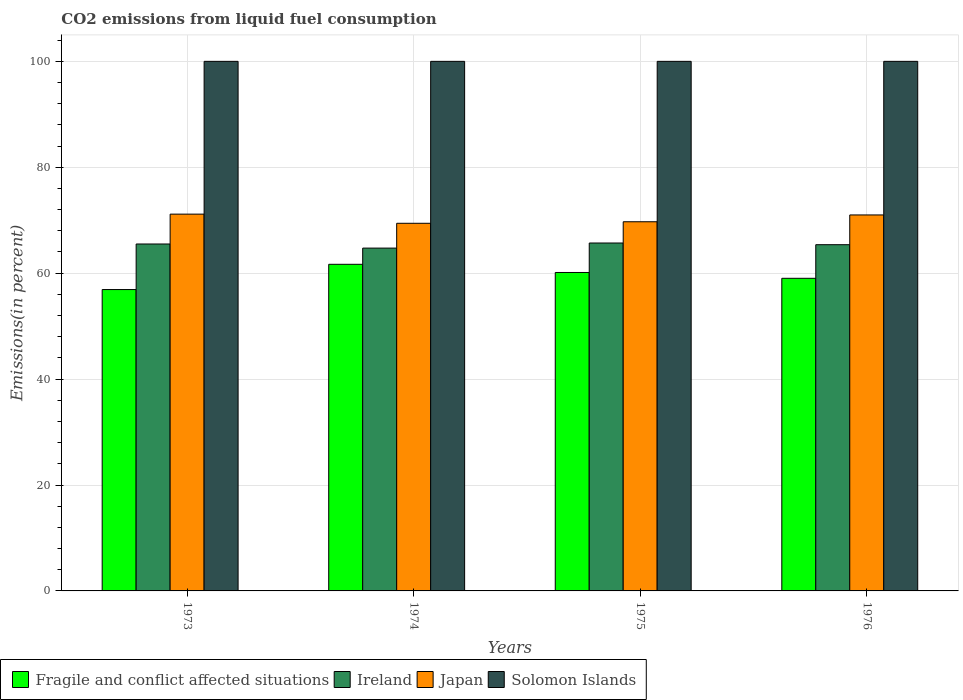How many groups of bars are there?
Your answer should be very brief. 4. Are the number of bars per tick equal to the number of legend labels?
Keep it short and to the point. Yes. Are the number of bars on each tick of the X-axis equal?
Give a very brief answer. Yes. What is the label of the 4th group of bars from the left?
Your response must be concise. 1976. In how many cases, is the number of bars for a given year not equal to the number of legend labels?
Make the answer very short. 0. What is the total CO2 emitted in Japan in 1974?
Your answer should be very brief. 69.42. Across all years, what is the maximum total CO2 emitted in Japan?
Provide a short and direct response. 71.15. Across all years, what is the minimum total CO2 emitted in Solomon Islands?
Give a very brief answer. 100. In which year was the total CO2 emitted in Japan maximum?
Provide a succinct answer. 1973. In which year was the total CO2 emitted in Ireland minimum?
Give a very brief answer. 1974. What is the total total CO2 emitted in Fragile and conflict affected situations in the graph?
Offer a very short reply. 237.75. What is the difference between the total CO2 emitted in Fragile and conflict affected situations in 1976 and the total CO2 emitted in Ireland in 1974?
Ensure brevity in your answer.  -5.7. What is the average total CO2 emitted in Ireland per year?
Offer a very short reply. 65.33. In the year 1973, what is the difference between the total CO2 emitted in Japan and total CO2 emitted in Ireland?
Give a very brief answer. 5.64. In how many years, is the total CO2 emitted in Ireland greater than 40 %?
Your response must be concise. 4. What is the ratio of the total CO2 emitted in Solomon Islands in 1975 to that in 1976?
Ensure brevity in your answer.  1. Is the total CO2 emitted in Fragile and conflict affected situations in 1973 less than that in 1975?
Keep it short and to the point. Yes. Is the difference between the total CO2 emitted in Japan in 1974 and 1975 greater than the difference between the total CO2 emitted in Ireland in 1974 and 1975?
Provide a succinct answer. Yes. What is the difference between the highest and the second highest total CO2 emitted in Fragile and conflict affected situations?
Provide a succinct answer. 1.54. What is the difference between the highest and the lowest total CO2 emitted in Solomon Islands?
Your answer should be very brief. 0. What does the 3rd bar from the right in 1974 represents?
Offer a very short reply. Ireland. Are all the bars in the graph horizontal?
Provide a short and direct response. No. How many years are there in the graph?
Your answer should be compact. 4. What is the difference between two consecutive major ticks on the Y-axis?
Provide a succinct answer. 20. Are the values on the major ticks of Y-axis written in scientific E-notation?
Provide a succinct answer. No. Does the graph contain grids?
Your response must be concise. Yes. How are the legend labels stacked?
Provide a short and direct response. Horizontal. What is the title of the graph?
Offer a very short reply. CO2 emissions from liquid fuel consumption. Does "New Caledonia" appear as one of the legend labels in the graph?
Provide a succinct answer. No. What is the label or title of the X-axis?
Give a very brief answer. Years. What is the label or title of the Y-axis?
Offer a very short reply. Emissions(in percent). What is the Emissions(in percent) of Fragile and conflict affected situations in 1973?
Your answer should be compact. 56.91. What is the Emissions(in percent) in Ireland in 1973?
Your response must be concise. 65.51. What is the Emissions(in percent) of Japan in 1973?
Make the answer very short. 71.15. What is the Emissions(in percent) in Solomon Islands in 1973?
Give a very brief answer. 100. What is the Emissions(in percent) in Fragile and conflict affected situations in 1974?
Your answer should be very brief. 61.68. What is the Emissions(in percent) of Ireland in 1974?
Keep it short and to the point. 64.74. What is the Emissions(in percent) of Japan in 1974?
Your response must be concise. 69.42. What is the Emissions(in percent) of Solomon Islands in 1974?
Make the answer very short. 100. What is the Emissions(in percent) of Fragile and conflict affected situations in 1975?
Provide a succinct answer. 60.13. What is the Emissions(in percent) in Ireland in 1975?
Give a very brief answer. 65.7. What is the Emissions(in percent) in Japan in 1975?
Your response must be concise. 69.71. What is the Emissions(in percent) in Fragile and conflict affected situations in 1976?
Provide a short and direct response. 59.03. What is the Emissions(in percent) of Ireland in 1976?
Offer a terse response. 65.38. What is the Emissions(in percent) in Japan in 1976?
Provide a short and direct response. 71. Across all years, what is the maximum Emissions(in percent) of Fragile and conflict affected situations?
Provide a short and direct response. 61.68. Across all years, what is the maximum Emissions(in percent) in Ireland?
Provide a short and direct response. 65.7. Across all years, what is the maximum Emissions(in percent) in Japan?
Offer a very short reply. 71.15. Across all years, what is the maximum Emissions(in percent) in Solomon Islands?
Offer a very short reply. 100. Across all years, what is the minimum Emissions(in percent) of Fragile and conflict affected situations?
Offer a terse response. 56.91. Across all years, what is the minimum Emissions(in percent) of Ireland?
Your response must be concise. 64.74. Across all years, what is the minimum Emissions(in percent) of Japan?
Ensure brevity in your answer.  69.42. Across all years, what is the minimum Emissions(in percent) in Solomon Islands?
Keep it short and to the point. 100. What is the total Emissions(in percent) of Fragile and conflict affected situations in the graph?
Keep it short and to the point. 237.75. What is the total Emissions(in percent) in Ireland in the graph?
Provide a succinct answer. 261.32. What is the total Emissions(in percent) in Japan in the graph?
Provide a short and direct response. 281.28. What is the difference between the Emissions(in percent) in Fragile and conflict affected situations in 1973 and that in 1974?
Provide a short and direct response. -4.77. What is the difference between the Emissions(in percent) of Ireland in 1973 and that in 1974?
Provide a short and direct response. 0.78. What is the difference between the Emissions(in percent) of Japan in 1973 and that in 1974?
Your answer should be very brief. 1.73. What is the difference between the Emissions(in percent) in Fragile and conflict affected situations in 1973 and that in 1975?
Provide a succinct answer. -3.23. What is the difference between the Emissions(in percent) of Ireland in 1973 and that in 1975?
Your answer should be compact. -0.18. What is the difference between the Emissions(in percent) of Japan in 1973 and that in 1975?
Your answer should be compact. 1.44. What is the difference between the Emissions(in percent) of Solomon Islands in 1973 and that in 1975?
Keep it short and to the point. 0. What is the difference between the Emissions(in percent) of Fragile and conflict affected situations in 1973 and that in 1976?
Offer a terse response. -2.12. What is the difference between the Emissions(in percent) in Ireland in 1973 and that in 1976?
Provide a short and direct response. 0.13. What is the difference between the Emissions(in percent) of Japan in 1973 and that in 1976?
Ensure brevity in your answer.  0.15. What is the difference between the Emissions(in percent) in Fragile and conflict affected situations in 1974 and that in 1975?
Give a very brief answer. 1.54. What is the difference between the Emissions(in percent) of Ireland in 1974 and that in 1975?
Provide a short and direct response. -0.96. What is the difference between the Emissions(in percent) in Japan in 1974 and that in 1975?
Give a very brief answer. -0.29. What is the difference between the Emissions(in percent) in Fragile and conflict affected situations in 1974 and that in 1976?
Give a very brief answer. 2.65. What is the difference between the Emissions(in percent) in Ireland in 1974 and that in 1976?
Give a very brief answer. -0.64. What is the difference between the Emissions(in percent) in Japan in 1974 and that in 1976?
Provide a succinct answer. -1.58. What is the difference between the Emissions(in percent) of Solomon Islands in 1974 and that in 1976?
Provide a short and direct response. 0. What is the difference between the Emissions(in percent) in Fragile and conflict affected situations in 1975 and that in 1976?
Offer a terse response. 1.1. What is the difference between the Emissions(in percent) of Ireland in 1975 and that in 1976?
Provide a succinct answer. 0.32. What is the difference between the Emissions(in percent) in Japan in 1975 and that in 1976?
Provide a short and direct response. -1.29. What is the difference between the Emissions(in percent) of Fragile and conflict affected situations in 1973 and the Emissions(in percent) of Ireland in 1974?
Your response must be concise. -7.83. What is the difference between the Emissions(in percent) of Fragile and conflict affected situations in 1973 and the Emissions(in percent) of Japan in 1974?
Provide a succinct answer. -12.51. What is the difference between the Emissions(in percent) in Fragile and conflict affected situations in 1973 and the Emissions(in percent) in Solomon Islands in 1974?
Your answer should be very brief. -43.09. What is the difference between the Emissions(in percent) of Ireland in 1973 and the Emissions(in percent) of Japan in 1974?
Give a very brief answer. -3.91. What is the difference between the Emissions(in percent) of Ireland in 1973 and the Emissions(in percent) of Solomon Islands in 1974?
Ensure brevity in your answer.  -34.49. What is the difference between the Emissions(in percent) of Japan in 1973 and the Emissions(in percent) of Solomon Islands in 1974?
Your answer should be very brief. -28.85. What is the difference between the Emissions(in percent) of Fragile and conflict affected situations in 1973 and the Emissions(in percent) of Ireland in 1975?
Your answer should be very brief. -8.79. What is the difference between the Emissions(in percent) of Fragile and conflict affected situations in 1973 and the Emissions(in percent) of Japan in 1975?
Make the answer very short. -12.8. What is the difference between the Emissions(in percent) of Fragile and conflict affected situations in 1973 and the Emissions(in percent) of Solomon Islands in 1975?
Your answer should be very brief. -43.09. What is the difference between the Emissions(in percent) of Ireland in 1973 and the Emissions(in percent) of Japan in 1975?
Make the answer very short. -4.2. What is the difference between the Emissions(in percent) of Ireland in 1973 and the Emissions(in percent) of Solomon Islands in 1975?
Keep it short and to the point. -34.49. What is the difference between the Emissions(in percent) in Japan in 1973 and the Emissions(in percent) in Solomon Islands in 1975?
Make the answer very short. -28.85. What is the difference between the Emissions(in percent) of Fragile and conflict affected situations in 1973 and the Emissions(in percent) of Ireland in 1976?
Provide a short and direct response. -8.47. What is the difference between the Emissions(in percent) of Fragile and conflict affected situations in 1973 and the Emissions(in percent) of Japan in 1976?
Provide a succinct answer. -14.09. What is the difference between the Emissions(in percent) in Fragile and conflict affected situations in 1973 and the Emissions(in percent) in Solomon Islands in 1976?
Ensure brevity in your answer.  -43.09. What is the difference between the Emissions(in percent) of Ireland in 1973 and the Emissions(in percent) of Japan in 1976?
Your answer should be very brief. -5.48. What is the difference between the Emissions(in percent) of Ireland in 1973 and the Emissions(in percent) of Solomon Islands in 1976?
Offer a terse response. -34.49. What is the difference between the Emissions(in percent) in Japan in 1973 and the Emissions(in percent) in Solomon Islands in 1976?
Your response must be concise. -28.85. What is the difference between the Emissions(in percent) of Fragile and conflict affected situations in 1974 and the Emissions(in percent) of Ireland in 1975?
Provide a short and direct response. -4.02. What is the difference between the Emissions(in percent) of Fragile and conflict affected situations in 1974 and the Emissions(in percent) of Japan in 1975?
Ensure brevity in your answer.  -8.03. What is the difference between the Emissions(in percent) in Fragile and conflict affected situations in 1974 and the Emissions(in percent) in Solomon Islands in 1975?
Offer a very short reply. -38.32. What is the difference between the Emissions(in percent) in Ireland in 1974 and the Emissions(in percent) in Japan in 1975?
Give a very brief answer. -4.97. What is the difference between the Emissions(in percent) of Ireland in 1974 and the Emissions(in percent) of Solomon Islands in 1975?
Keep it short and to the point. -35.26. What is the difference between the Emissions(in percent) in Japan in 1974 and the Emissions(in percent) in Solomon Islands in 1975?
Your answer should be compact. -30.58. What is the difference between the Emissions(in percent) of Fragile and conflict affected situations in 1974 and the Emissions(in percent) of Ireland in 1976?
Ensure brevity in your answer.  -3.7. What is the difference between the Emissions(in percent) in Fragile and conflict affected situations in 1974 and the Emissions(in percent) in Japan in 1976?
Provide a short and direct response. -9.32. What is the difference between the Emissions(in percent) of Fragile and conflict affected situations in 1974 and the Emissions(in percent) of Solomon Islands in 1976?
Offer a very short reply. -38.32. What is the difference between the Emissions(in percent) in Ireland in 1974 and the Emissions(in percent) in Japan in 1976?
Keep it short and to the point. -6.26. What is the difference between the Emissions(in percent) in Ireland in 1974 and the Emissions(in percent) in Solomon Islands in 1976?
Ensure brevity in your answer.  -35.26. What is the difference between the Emissions(in percent) of Japan in 1974 and the Emissions(in percent) of Solomon Islands in 1976?
Offer a terse response. -30.58. What is the difference between the Emissions(in percent) of Fragile and conflict affected situations in 1975 and the Emissions(in percent) of Ireland in 1976?
Keep it short and to the point. -5.24. What is the difference between the Emissions(in percent) in Fragile and conflict affected situations in 1975 and the Emissions(in percent) in Japan in 1976?
Offer a very short reply. -10.86. What is the difference between the Emissions(in percent) in Fragile and conflict affected situations in 1975 and the Emissions(in percent) in Solomon Islands in 1976?
Ensure brevity in your answer.  -39.87. What is the difference between the Emissions(in percent) of Ireland in 1975 and the Emissions(in percent) of Japan in 1976?
Provide a succinct answer. -5.3. What is the difference between the Emissions(in percent) of Ireland in 1975 and the Emissions(in percent) of Solomon Islands in 1976?
Make the answer very short. -34.3. What is the difference between the Emissions(in percent) in Japan in 1975 and the Emissions(in percent) in Solomon Islands in 1976?
Your response must be concise. -30.29. What is the average Emissions(in percent) in Fragile and conflict affected situations per year?
Your answer should be compact. 59.44. What is the average Emissions(in percent) of Ireland per year?
Your response must be concise. 65.33. What is the average Emissions(in percent) of Japan per year?
Keep it short and to the point. 70.32. What is the average Emissions(in percent) of Solomon Islands per year?
Your answer should be very brief. 100. In the year 1973, what is the difference between the Emissions(in percent) of Fragile and conflict affected situations and Emissions(in percent) of Ireland?
Your answer should be compact. -8.6. In the year 1973, what is the difference between the Emissions(in percent) in Fragile and conflict affected situations and Emissions(in percent) in Japan?
Give a very brief answer. -14.24. In the year 1973, what is the difference between the Emissions(in percent) in Fragile and conflict affected situations and Emissions(in percent) in Solomon Islands?
Your answer should be compact. -43.09. In the year 1973, what is the difference between the Emissions(in percent) in Ireland and Emissions(in percent) in Japan?
Offer a very short reply. -5.64. In the year 1973, what is the difference between the Emissions(in percent) in Ireland and Emissions(in percent) in Solomon Islands?
Provide a succinct answer. -34.49. In the year 1973, what is the difference between the Emissions(in percent) of Japan and Emissions(in percent) of Solomon Islands?
Your response must be concise. -28.85. In the year 1974, what is the difference between the Emissions(in percent) in Fragile and conflict affected situations and Emissions(in percent) in Ireland?
Provide a succinct answer. -3.06. In the year 1974, what is the difference between the Emissions(in percent) in Fragile and conflict affected situations and Emissions(in percent) in Japan?
Your answer should be very brief. -7.74. In the year 1974, what is the difference between the Emissions(in percent) in Fragile and conflict affected situations and Emissions(in percent) in Solomon Islands?
Provide a short and direct response. -38.32. In the year 1974, what is the difference between the Emissions(in percent) of Ireland and Emissions(in percent) of Japan?
Offer a very short reply. -4.68. In the year 1974, what is the difference between the Emissions(in percent) of Ireland and Emissions(in percent) of Solomon Islands?
Offer a very short reply. -35.26. In the year 1974, what is the difference between the Emissions(in percent) of Japan and Emissions(in percent) of Solomon Islands?
Offer a terse response. -30.58. In the year 1975, what is the difference between the Emissions(in percent) in Fragile and conflict affected situations and Emissions(in percent) in Ireland?
Ensure brevity in your answer.  -5.56. In the year 1975, what is the difference between the Emissions(in percent) in Fragile and conflict affected situations and Emissions(in percent) in Japan?
Provide a succinct answer. -9.58. In the year 1975, what is the difference between the Emissions(in percent) in Fragile and conflict affected situations and Emissions(in percent) in Solomon Islands?
Offer a very short reply. -39.87. In the year 1975, what is the difference between the Emissions(in percent) of Ireland and Emissions(in percent) of Japan?
Your response must be concise. -4.01. In the year 1975, what is the difference between the Emissions(in percent) of Ireland and Emissions(in percent) of Solomon Islands?
Give a very brief answer. -34.3. In the year 1975, what is the difference between the Emissions(in percent) in Japan and Emissions(in percent) in Solomon Islands?
Ensure brevity in your answer.  -30.29. In the year 1976, what is the difference between the Emissions(in percent) in Fragile and conflict affected situations and Emissions(in percent) in Ireland?
Keep it short and to the point. -6.35. In the year 1976, what is the difference between the Emissions(in percent) in Fragile and conflict affected situations and Emissions(in percent) in Japan?
Give a very brief answer. -11.96. In the year 1976, what is the difference between the Emissions(in percent) in Fragile and conflict affected situations and Emissions(in percent) in Solomon Islands?
Provide a succinct answer. -40.97. In the year 1976, what is the difference between the Emissions(in percent) of Ireland and Emissions(in percent) of Japan?
Give a very brief answer. -5.62. In the year 1976, what is the difference between the Emissions(in percent) in Ireland and Emissions(in percent) in Solomon Islands?
Offer a terse response. -34.62. In the year 1976, what is the difference between the Emissions(in percent) in Japan and Emissions(in percent) in Solomon Islands?
Your answer should be compact. -29. What is the ratio of the Emissions(in percent) of Fragile and conflict affected situations in 1973 to that in 1974?
Provide a succinct answer. 0.92. What is the ratio of the Emissions(in percent) in Ireland in 1973 to that in 1974?
Your answer should be very brief. 1.01. What is the ratio of the Emissions(in percent) in Japan in 1973 to that in 1974?
Offer a terse response. 1.02. What is the ratio of the Emissions(in percent) in Solomon Islands in 1973 to that in 1974?
Make the answer very short. 1. What is the ratio of the Emissions(in percent) in Fragile and conflict affected situations in 1973 to that in 1975?
Your answer should be very brief. 0.95. What is the ratio of the Emissions(in percent) in Ireland in 1973 to that in 1975?
Ensure brevity in your answer.  1. What is the ratio of the Emissions(in percent) in Japan in 1973 to that in 1975?
Your answer should be very brief. 1.02. What is the ratio of the Emissions(in percent) in Fragile and conflict affected situations in 1973 to that in 1976?
Give a very brief answer. 0.96. What is the ratio of the Emissions(in percent) of Fragile and conflict affected situations in 1974 to that in 1975?
Your response must be concise. 1.03. What is the ratio of the Emissions(in percent) of Ireland in 1974 to that in 1975?
Provide a succinct answer. 0.99. What is the ratio of the Emissions(in percent) in Japan in 1974 to that in 1975?
Keep it short and to the point. 1. What is the ratio of the Emissions(in percent) in Solomon Islands in 1974 to that in 1975?
Your answer should be very brief. 1. What is the ratio of the Emissions(in percent) of Fragile and conflict affected situations in 1974 to that in 1976?
Provide a short and direct response. 1.04. What is the ratio of the Emissions(in percent) of Ireland in 1974 to that in 1976?
Provide a succinct answer. 0.99. What is the ratio of the Emissions(in percent) of Japan in 1974 to that in 1976?
Your answer should be very brief. 0.98. What is the ratio of the Emissions(in percent) in Fragile and conflict affected situations in 1975 to that in 1976?
Provide a succinct answer. 1.02. What is the ratio of the Emissions(in percent) in Japan in 1975 to that in 1976?
Make the answer very short. 0.98. What is the ratio of the Emissions(in percent) of Solomon Islands in 1975 to that in 1976?
Provide a succinct answer. 1. What is the difference between the highest and the second highest Emissions(in percent) of Fragile and conflict affected situations?
Offer a terse response. 1.54. What is the difference between the highest and the second highest Emissions(in percent) of Ireland?
Provide a short and direct response. 0.18. What is the difference between the highest and the second highest Emissions(in percent) in Japan?
Keep it short and to the point. 0.15. What is the difference between the highest and the lowest Emissions(in percent) of Fragile and conflict affected situations?
Provide a short and direct response. 4.77. What is the difference between the highest and the lowest Emissions(in percent) in Ireland?
Give a very brief answer. 0.96. What is the difference between the highest and the lowest Emissions(in percent) of Japan?
Provide a short and direct response. 1.73. What is the difference between the highest and the lowest Emissions(in percent) of Solomon Islands?
Your answer should be compact. 0. 